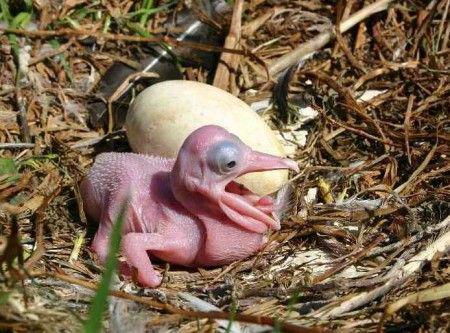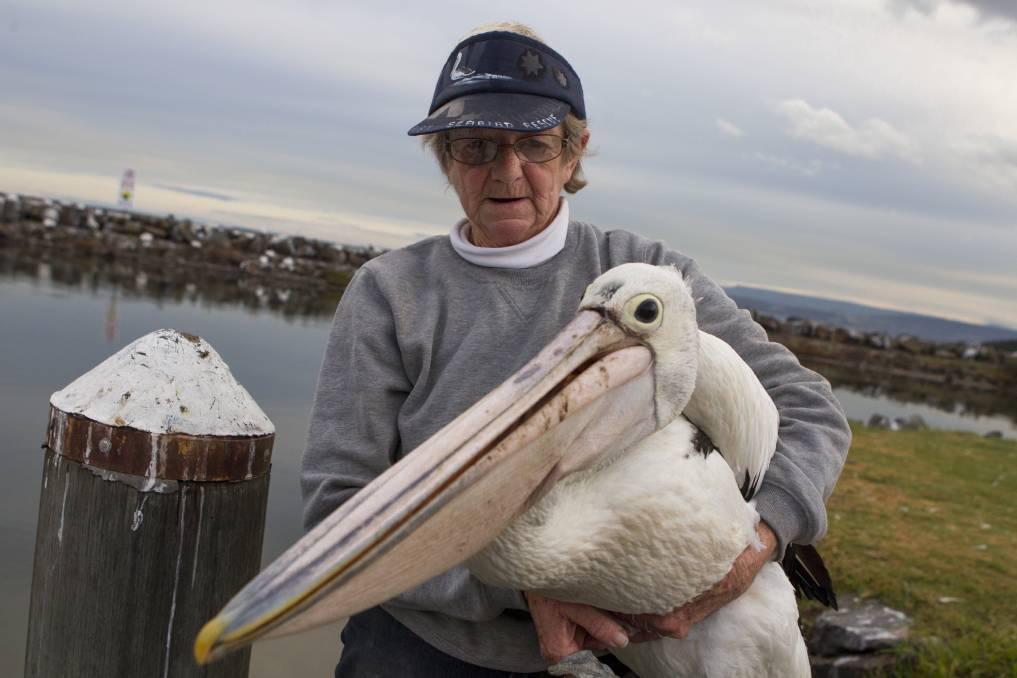The first image is the image on the left, the second image is the image on the right. For the images shown, is this caption "There are exactly four birds." true? Answer yes or no. No. The first image is the image on the left, the second image is the image on the right. Evaluate the accuracy of this statement regarding the images: "Each image shows exactly two pelicans posed close together.". Is it true? Answer yes or no. No. 